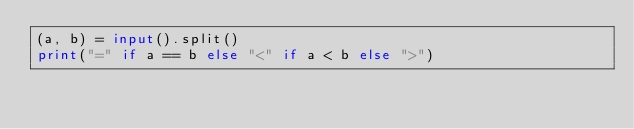<code> <loc_0><loc_0><loc_500><loc_500><_Python_>(a, b) = input().split()
print("=" if a == b else "<" if a < b else ">")</code> 